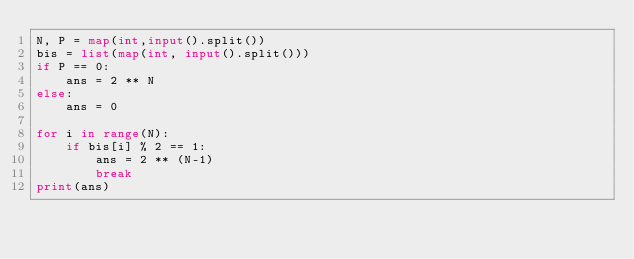<code> <loc_0><loc_0><loc_500><loc_500><_Python_>N, P = map(int,input().split())
bis = list(map(int, input().split()))
if P == 0:
    ans = 2 ** N
else:
    ans = 0

for i in range(N):
    if bis[i] % 2 == 1:
        ans = 2 ** (N-1)
        break
print(ans)</code> 